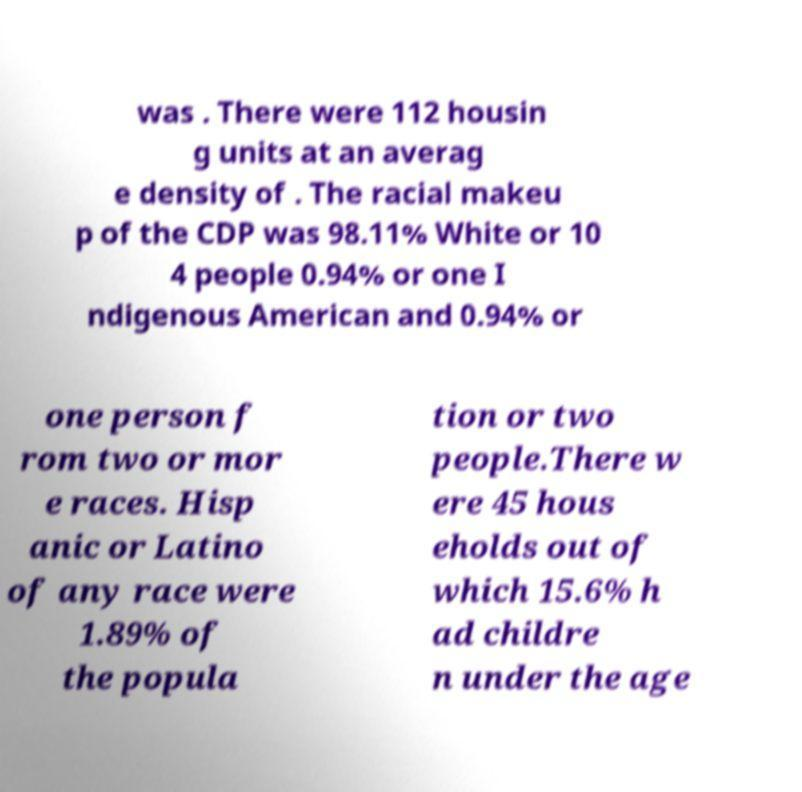Please identify and transcribe the text found in this image. was . There were 112 housin g units at an averag e density of . The racial makeu p of the CDP was 98.11% White or 10 4 people 0.94% or one I ndigenous American and 0.94% or one person f rom two or mor e races. Hisp anic or Latino of any race were 1.89% of the popula tion or two people.There w ere 45 hous eholds out of which 15.6% h ad childre n under the age 